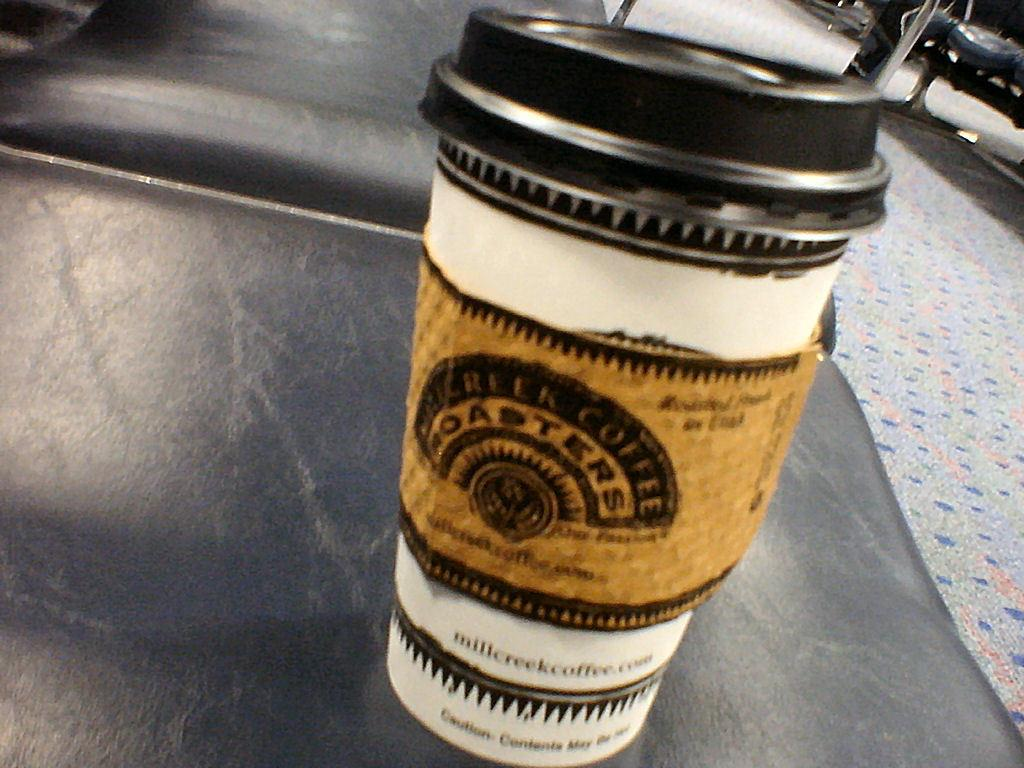<image>
Summarize the visual content of the image. A coffee in a to go cup from Mill Creek Coffee. 